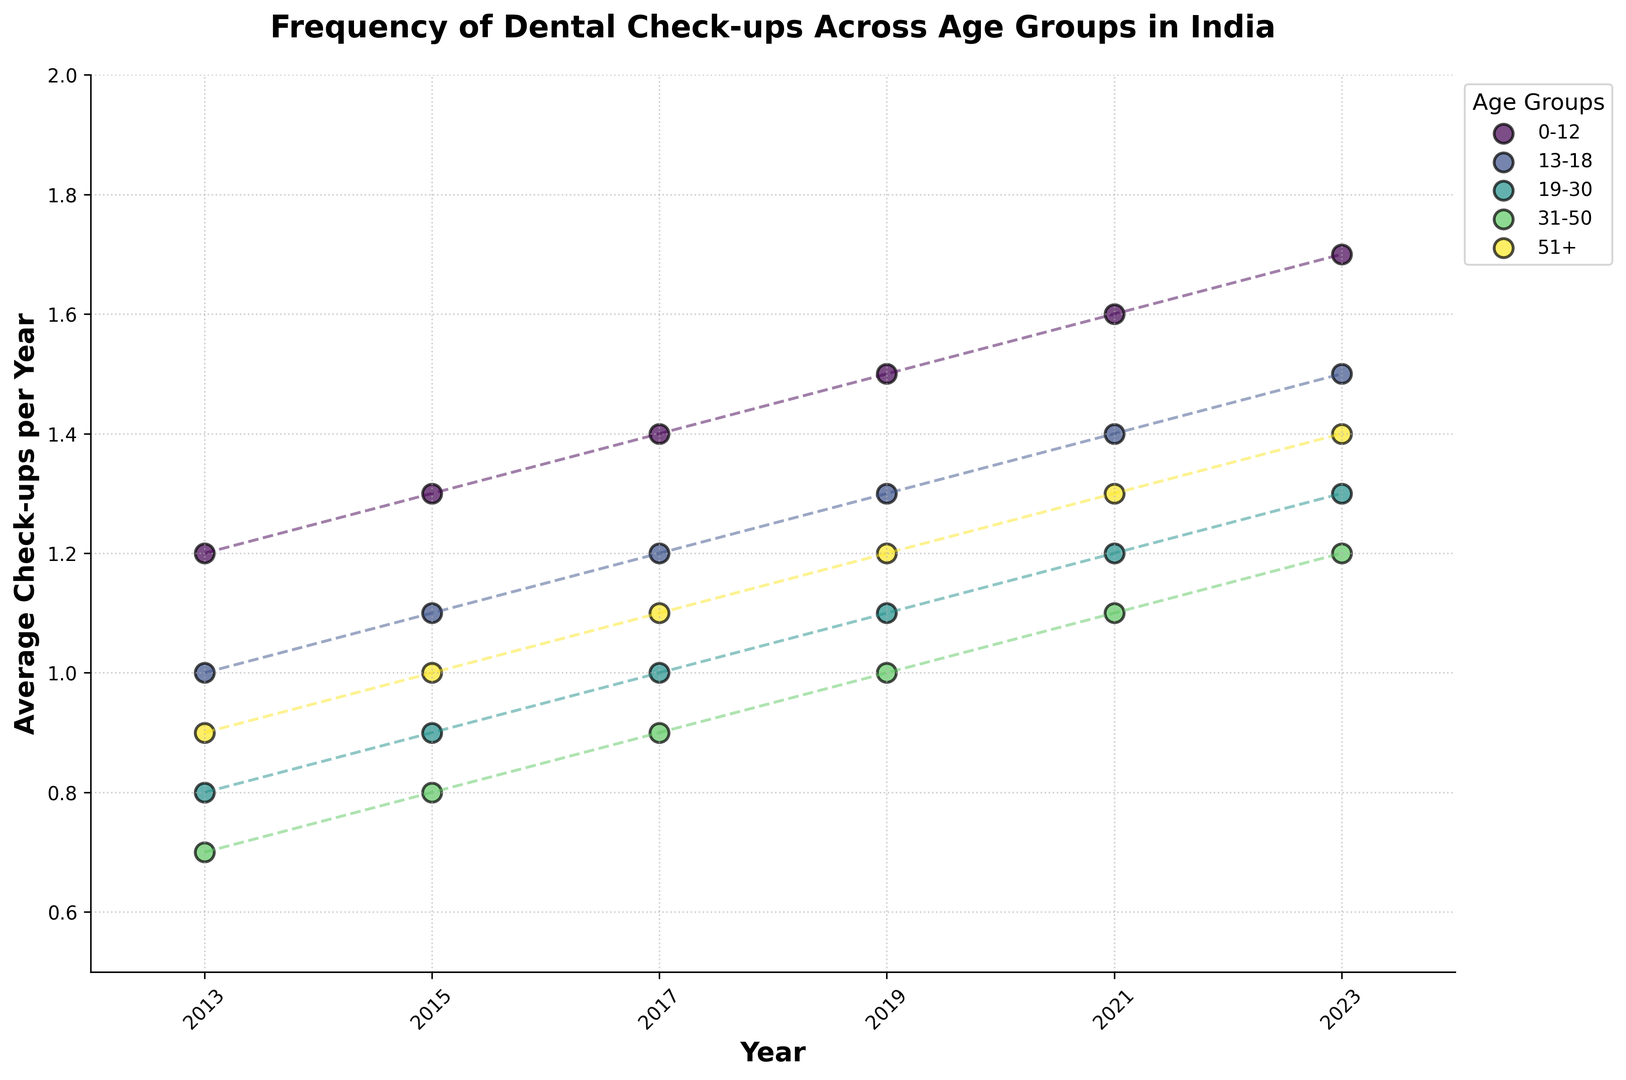What is the trend in the frequency of dental check-ups for the 0-12 age group from 2013 to 2023? To determine the trend, look at the scatter points connected by dashed lines for the 0-12 age group across the years 2013 to 2023. Notice the increasing pattern in the average check-ups per year. The frequency of check-ups increases from 1.2 in 2013 to 1.7 in 2023.
Answer: Increasing In which year did the 31-50 age group have the lowest frequency of dental check-ups? Identify the scatter points corresponding to the 31-50 age group across different years. The lowest point along the y-axis for the 31-50 group is 0.7 in 2013.
Answer: 2013 Which age group had the highest average check-ups per year in 2021? Compare the heights of the scatter points of different age groups in 2021. The 0-12 age group had the highest average check-ups per year at 1.6.
Answer: 0-12 How did the average check-ups for the 51+ age group change from 2015 to 2019? Look at the scatter points connected by dashed lines for the 51+ age group. Compare the values between 2015 (1.0) and 2019 (1.2). The average check-ups per year increased by 0.2.
Answer: Increased Which age group showed the most significant increase in frequency of dental check-ups from 2013 to 2023? Calculate the difference in check-ups for each age group from 2013 to 2023. The 0-12 age group showed an increase from 1.2 to 1.7, which is a 0.5 increase, the highest among all groups.
Answer: 0-12 How does the frequency of dental check-ups in 2019 for the 19-30 age group compare to the frequency in the 31-50 age group? Look at the scatter points for both age groups in 2019. The 19-30 group had an average of 1.1 check-ups while the 31-50 group had 1.0, showing that the 19-30 group had a slightly higher frequency.
Answer: Higher Did any age group ever experience a decrease in the frequency of dental check-ups during the period from 2013 to 2023? By examining each age group’s trends through the scatter points connected by dashed lines, we see that all age groups have an increasing or steady trend in the frequency of dental check-ups over time.
Answer: No What is the difference in the average check-ups between the youngest (0-12) and oldest (51+) age groups in 2023? Subtract the average check-ups of the 51+ group from the 0-12 group in 2023. It’s 1.7 (0-12) - 1.4 (51+), resulting in 0.3.
Answer: 0.3 Which age group had a consistent yearly increase in the frequency of dental check-ups from 2013 to 2023? The 0-12 age group shows a consistent year-on-year increase. Observe their points rising steadily on the scatter plot.
Answer: 0-12 What were the average check-ups per year for the 13-18 age group in 2017? Locate the scatter point for the 13-18 age group in 2017. The point on the y-axis shows 1.2 average check-ups per year.
Answer: 1.2 